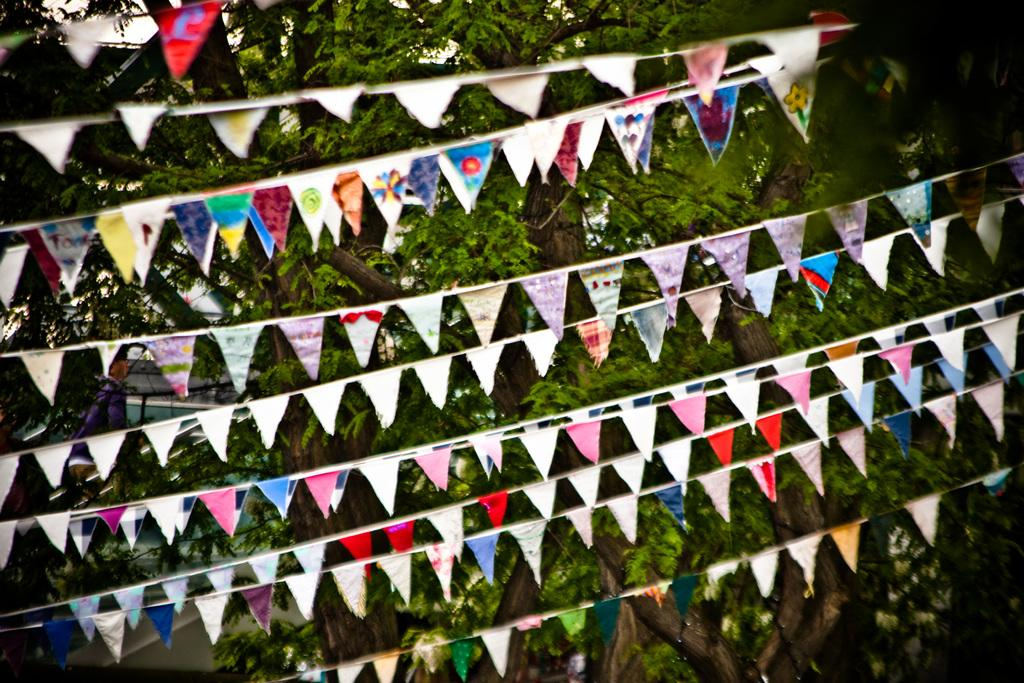What type of decoration items can be seen in the image? There are paper decoration items in the image. What natural elements are visible in the image? There are trees visible in the image. Is there a fire burning near the trees in the image? There is no fire present in the image; only trees and paper decoration items are visible. 